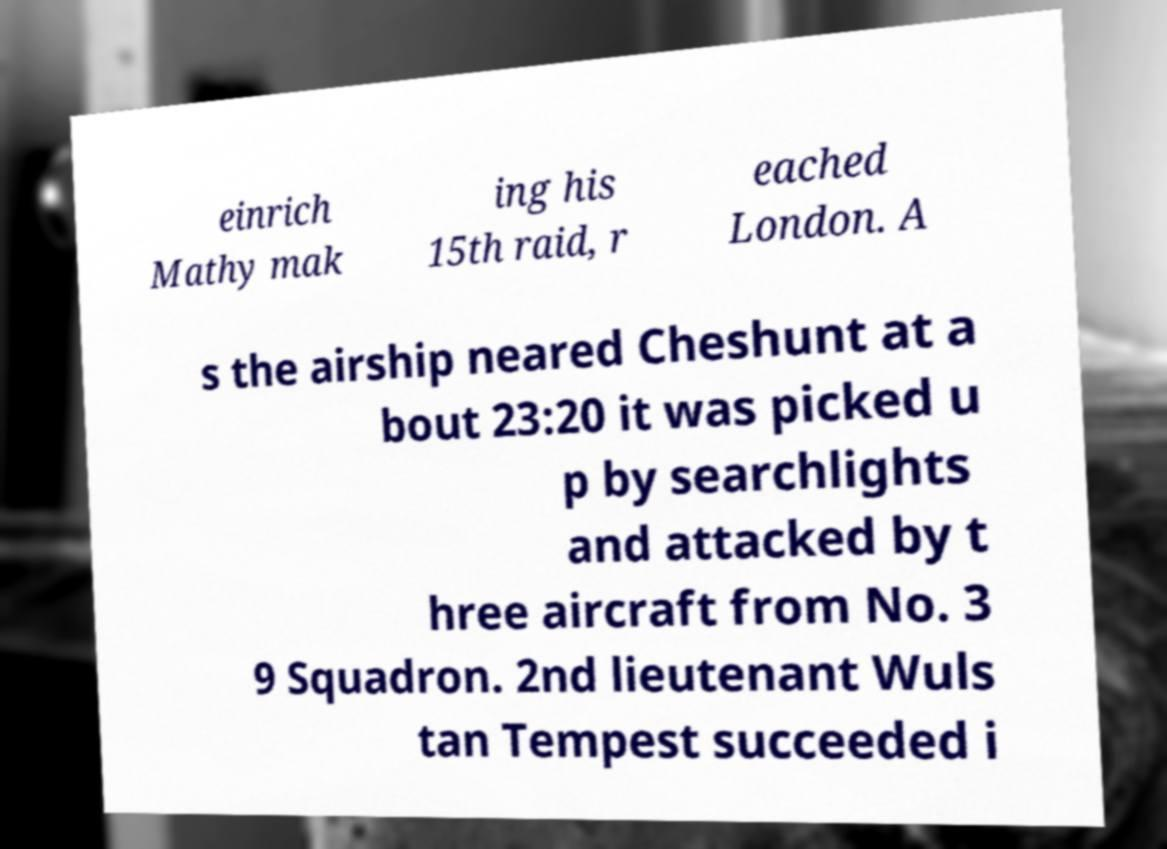Could you assist in decoding the text presented in this image and type it out clearly? einrich Mathy mak ing his 15th raid, r eached London. A s the airship neared Cheshunt at a bout 23:20 it was picked u p by searchlights and attacked by t hree aircraft from No. 3 9 Squadron. 2nd lieutenant Wuls tan Tempest succeeded i 